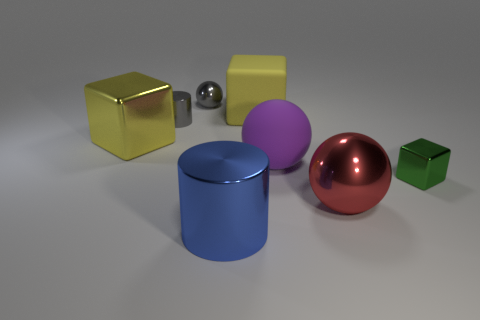What material is the cube that is behind the yellow cube that is to the left of the metal cylinder that is behind the small green metallic object?
Your response must be concise. Rubber. What number of metal objects are either tiny green blocks or small cyan spheres?
Give a very brief answer. 1. How many gray objects are small metallic spheres or shiny balls?
Offer a terse response. 1. There is a metal object that is left of the gray shiny cylinder; does it have the same color as the big matte block?
Offer a very short reply. Yes. Is the material of the small green object the same as the big blue object?
Provide a succinct answer. Yes. Is the number of tiny gray metal objects right of the large metallic cylinder the same as the number of big blue things to the left of the yellow metal cube?
Provide a short and direct response. Yes. There is a tiny object that is the same shape as the large yellow rubber thing; what material is it?
Offer a terse response. Metal. The purple rubber thing that is in front of the large yellow block left of the metal ball to the left of the red object is what shape?
Your answer should be very brief. Sphere. Is the number of large balls behind the green metal thing greater than the number of blue metal cubes?
Provide a succinct answer. Yes. There is a gray shiny object that is to the right of the small metal cylinder; is it the same shape as the purple matte object?
Ensure brevity in your answer.  Yes. 